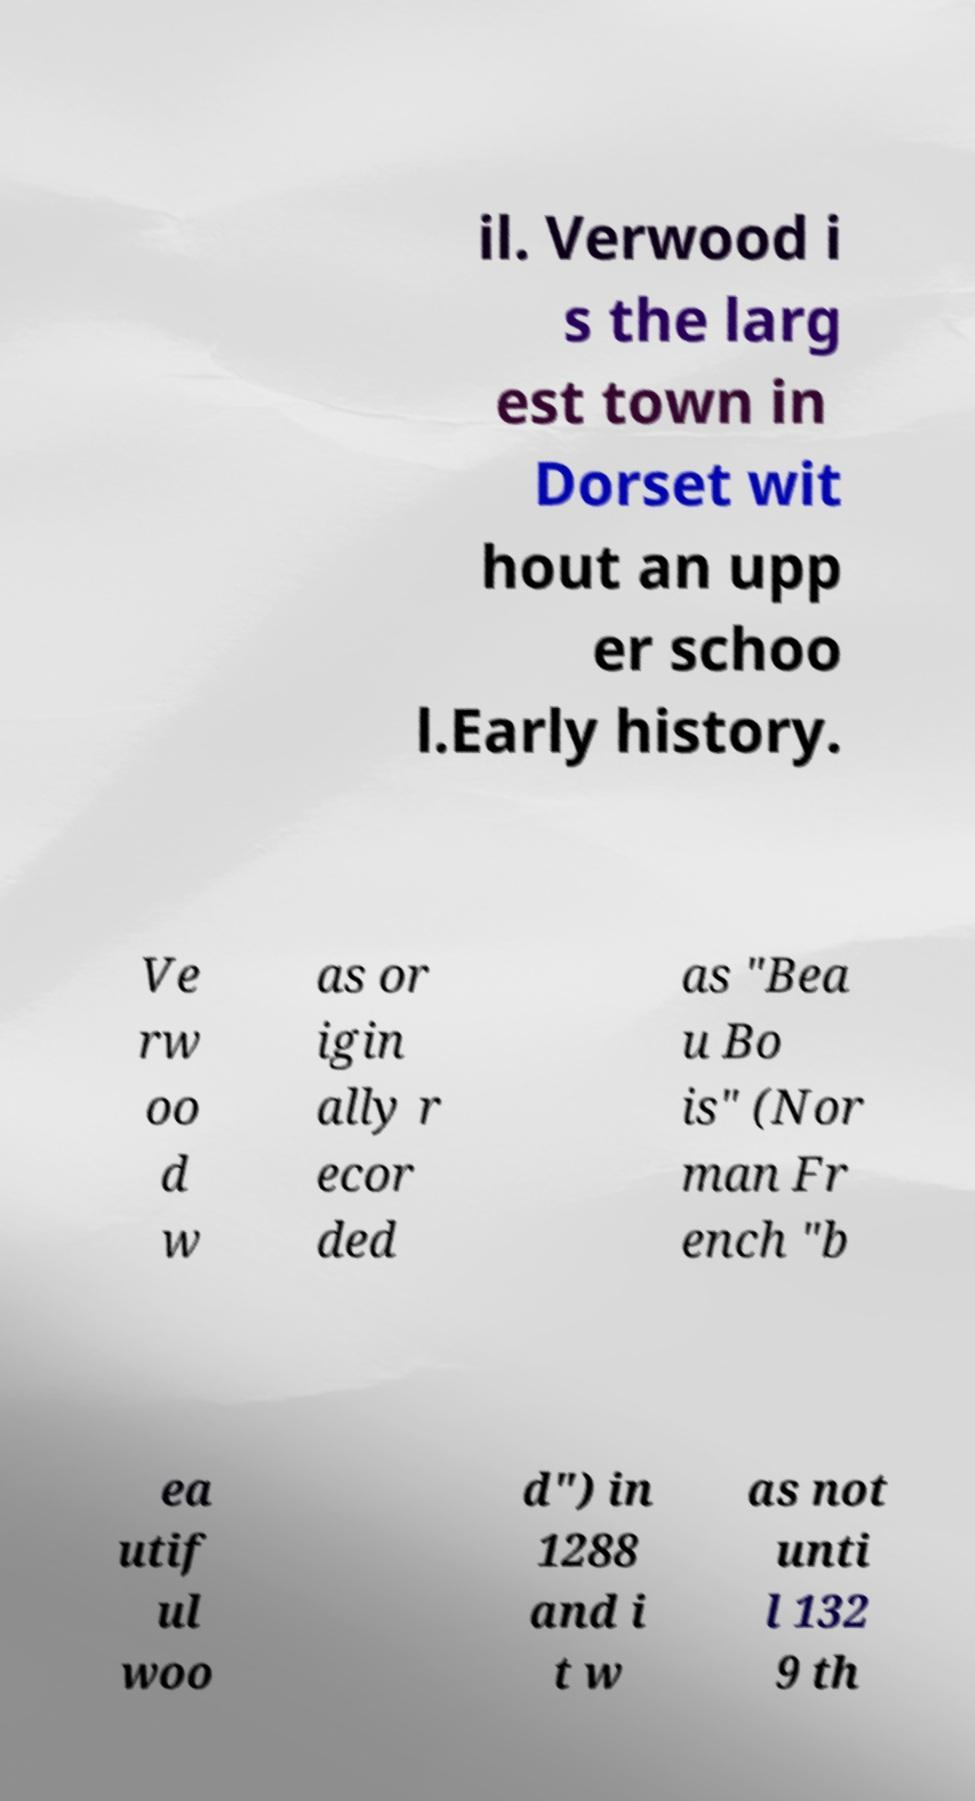Please read and relay the text visible in this image. What does it say? il. Verwood i s the larg est town in Dorset wit hout an upp er schoo l.Early history. Ve rw oo d w as or igin ally r ecor ded as "Bea u Bo is" (Nor man Fr ench "b ea utif ul woo d") in 1288 and i t w as not unti l 132 9 th 